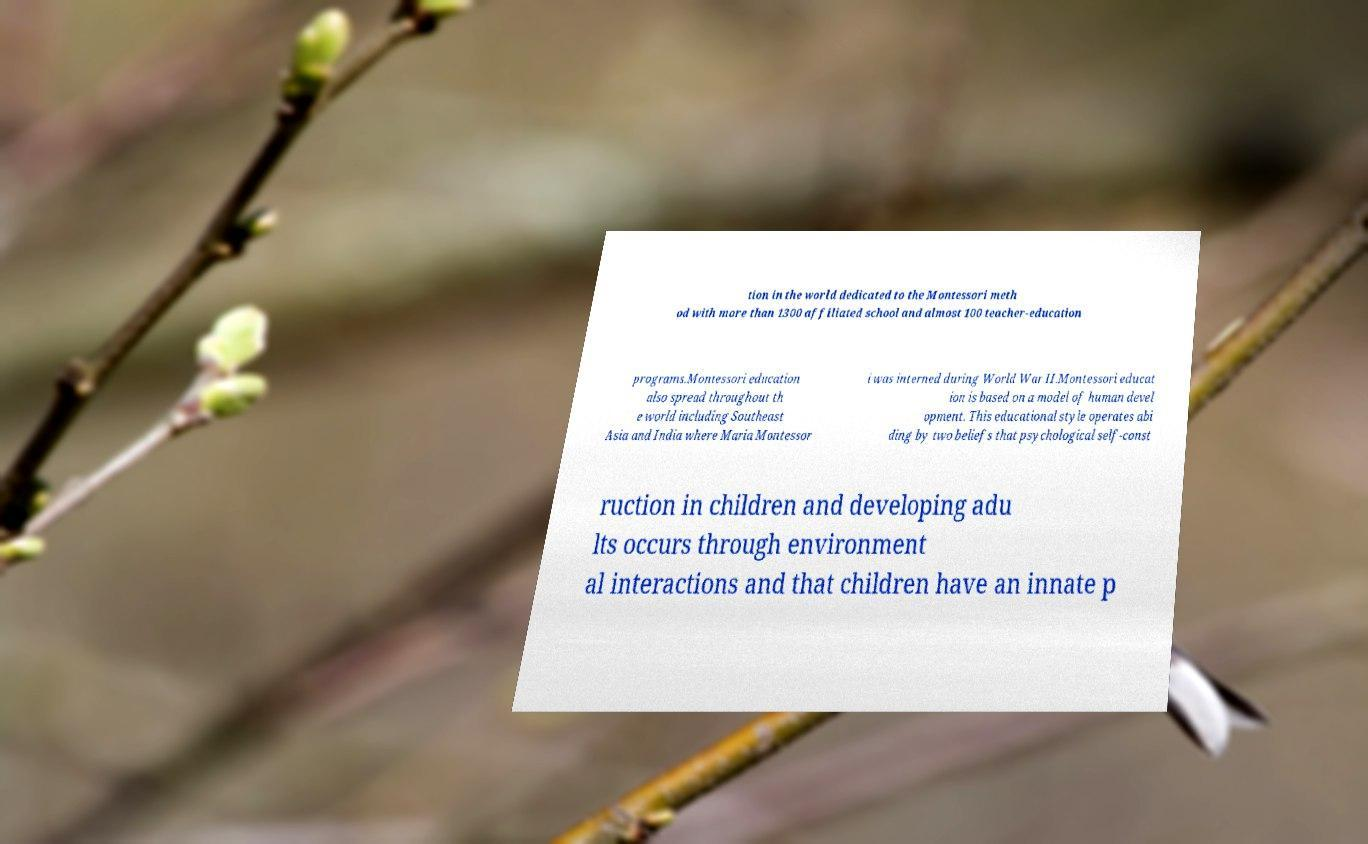Could you extract and type out the text from this image? tion in the world dedicated to the Montessori meth od with more than 1300 affiliated school and almost 100 teacher-education programs.Montessori education also spread throughout th e world including Southeast Asia and India where Maria Montessor i was interned during World War II.Montessori educat ion is based on a model of human devel opment. This educational style operates abi ding by two beliefs that psychological self-const ruction in children and developing adu lts occurs through environment al interactions and that children have an innate p 